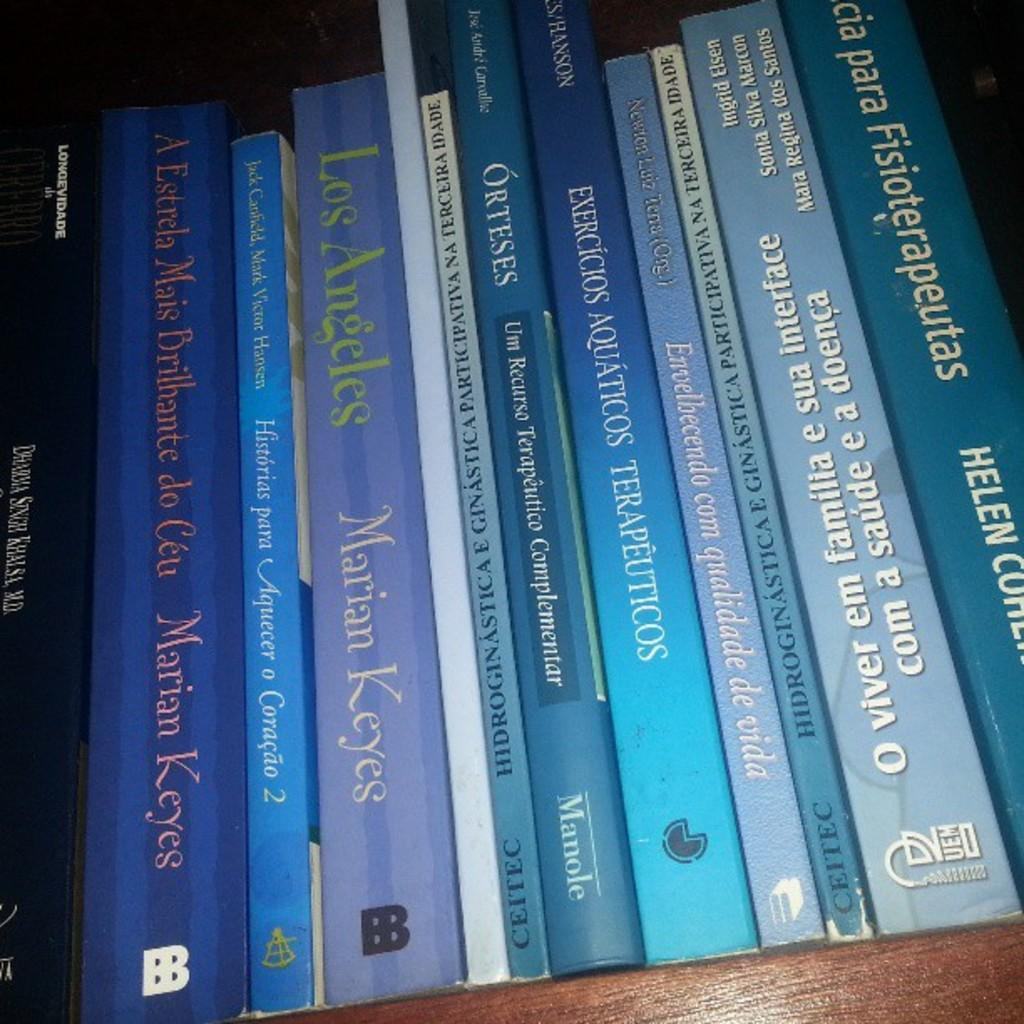<image>
Write a terse but informative summary of the picture. a set of books with one of them called los angeles by mariam keyes 